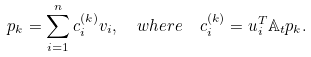Convert formula to latex. <formula><loc_0><loc_0><loc_500><loc_500>p _ { k } = \sum _ { i = 1 } ^ { n } c ^ { ( k ) } _ { i } v _ { i } , \ \ w h e r e \ \ c _ { i } ^ { ( k ) } = u _ { i } ^ { T } \mathbb { A } _ { t } p _ { k } .</formula> 